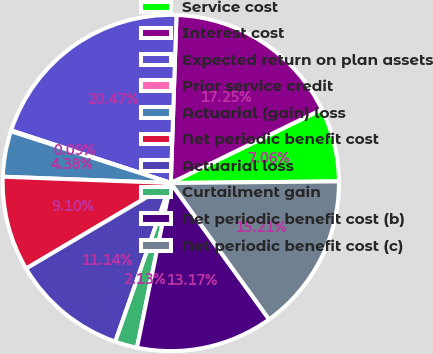Convert chart to OTSL. <chart><loc_0><loc_0><loc_500><loc_500><pie_chart><fcel>Service cost<fcel>Interest cost<fcel>Expected return on plan assets<fcel>Prior service credit<fcel>Actuarial (gain) loss<fcel>Net periodic benefit cost<fcel>Actuarial loss<fcel>Curtailment gain<fcel>Net periodic benefit cost (b)<fcel>Net periodic benefit cost (c)<nl><fcel>7.06%<fcel>17.25%<fcel>20.47%<fcel>0.09%<fcel>4.38%<fcel>9.1%<fcel>11.14%<fcel>2.13%<fcel>13.17%<fcel>15.21%<nl></chart> 